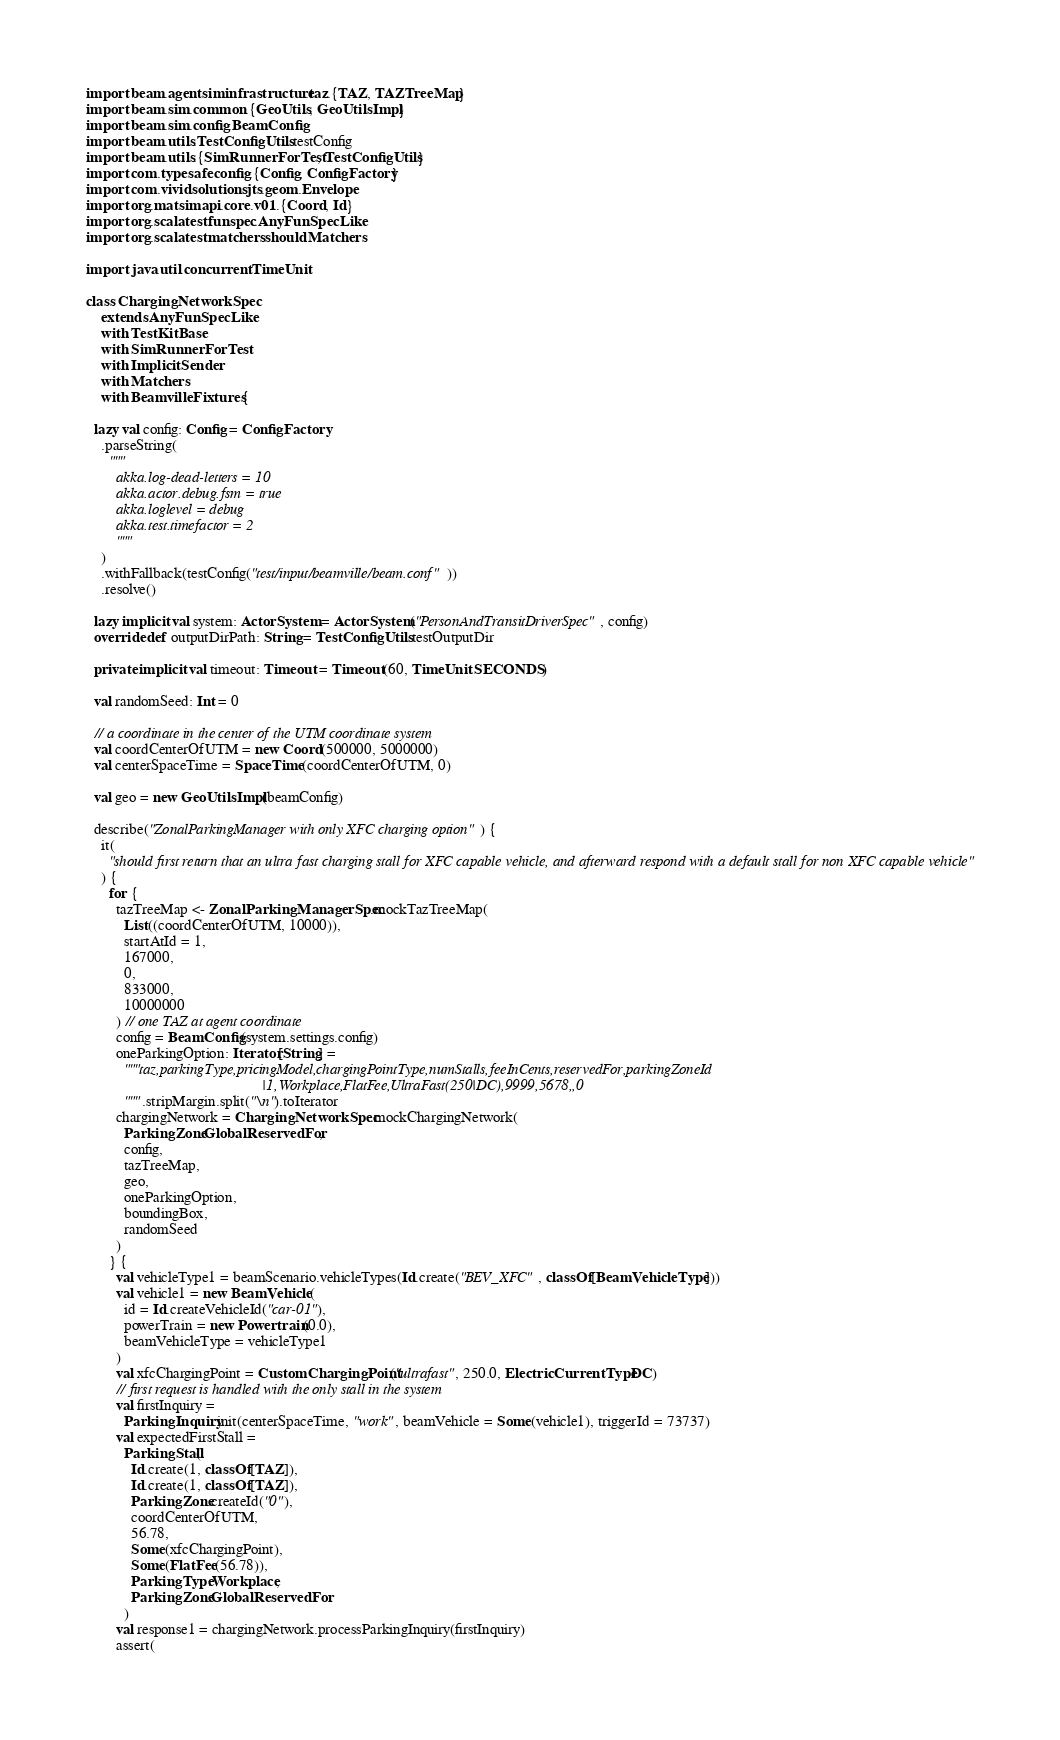<code> <loc_0><loc_0><loc_500><loc_500><_Scala_>import beam.agentsim.infrastructure.taz.{TAZ, TAZTreeMap}
import beam.sim.common.{GeoUtils, GeoUtilsImpl}
import beam.sim.config.BeamConfig
import beam.utils.TestConfigUtils.testConfig
import beam.utils.{SimRunnerForTest, TestConfigUtils}
import com.typesafe.config.{Config, ConfigFactory}
import com.vividsolutions.jts.geom.Envelope
import org.matsim.api.core.v01.{Coord, Id}
import org.scalatest.funspec.AnyFunSpecLike
import org.scalatest.matchers.should.Matchers

import java.util.concurrent.TimeUnit

class ChargingNetworkSpec
    extends AnyFunSpecLike
    with TestKitBase
    with SimRunnerForTest
    with ImplicitSender
    with Matchers
    with BeamvilleFixtures {

  lazy val config: Config = ConfigFactory
    .parseString(
      """
        akka.log-dead-letters = 10
        akka.actor.debug.fsm = true
        akka.loglevel = debug
        akka.test.timefactor = 2
        """
    )
    .withFallback(testConfig("test/input/beamville/beam.conf"))
    .resolve()

  lazy implicit val system: ActorSystem = ActorSystem("PersonAndTransitDriverSpec", config)
  override def outputDirPath: String = TestConfigUtils.testOutputDir

  private implicit val timeout: Timeout = Timeout(60, TimeUnit.SECONDS)

  val randomSeed: Int = 0

  // a coordinate in the center of the UTM coordinate system
  val coordCenterOfUTM = new Coord(500000, 5000000)
  val centerSpaceTime = SpaceTime(coordCenterOfUTM, 0)

  val geo = new GeoUtilsImpl(beamConfig)

  describe("ZonalParkingManager with only XFC charging option") {
    it(
      "should first return that an ultra fast charging stall for XFC capable vehicle, and afterward respond with a default stall for non XFC capable vehicle"
    ) {
      for {
        tazTreeMap <- ZonalParkingManagerSpec.mockTazTreeMap(
          List((coordCenterOfUTM, 10000)),
          startAtId = 1,
          167000,
          0,
          833000,
          10000000
        ) // one TAZ at agent coordinate
        config = BeamConfig(system.settings.config)
        oneParkingOption: Iterator[String] =
          """taz,parkingType,pricingModel,chargingPointType,numStalls,feeInCents,reservedFor,parkingZoneId
                                               |1,Workplace,FlatFee,UltraFast(250|DC),9999,5678,,0
          """.stripMargin.split("\n").toIterator
        chargingNetwork = ChargingNetworkSpec.mockChargingNetwork(
          ParkingZone.GlobalReservedFor,
          config,
          tazTreeMap,
          geo,
          oneParkingOption,
          boundingBox,
          randomSeed
        )
      } {
        val vehicleType1 = beamScenario.vehicleTypes(Id.create("BEV_XFC", classOf[BeamVehicleType]))
        val vehicle1 = new BeamVehicle(
          id = Id.createVehicleId("car-01"),
          powerTrain = new Powertrain(0.0),
          beamVehicleType = vehicleType1
        )
        val xfcChargingPoint = CustomChargingPoint("ultrafast", 250.0, ElectricCurrentType.DC)
        // first request is handled with the only stall in the system
        val firstInquiry =
          ParkingInquiry.init(centerSpaceTime, "work", beamVehicle = Some(vehicle1), triggerId = 73737)
        val expectedFirstStall =
          ParkingStall(
            Id.create(1, classOf[TAZ]),
            Id.create(1, classOf[TAZ]),
            ParkingZone.createId("0"),
            coordCenterOfUTM,
            56.78,
            Some(xfcChargingPoint),
            Some(FlatFee(56.78)),
            ParkingType.Workplace,
            ParkingZone.GlobalReservedFor
          )
        val response1 = chargingNetwork.processParkingInquiry(firstInquiry)
        assert(</code> 